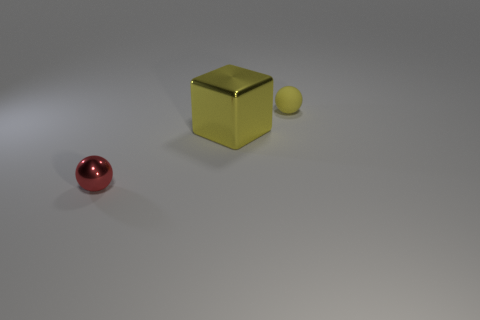Add 1 big red blocks. How many objects exist? 4 Subtract all cubes. How many objects are left? 2 Subtract all small rubber objects. Subtract all big yellow metal cubes. How many objects are left? 1 Add 2 big yellow objects. How many big yellow objects are left? 3 Add 1 large yellow matte cylinders. How many large yellow matte cylinders exist? 1 Subtract 0 red cylinders. How many objects are left? 3 